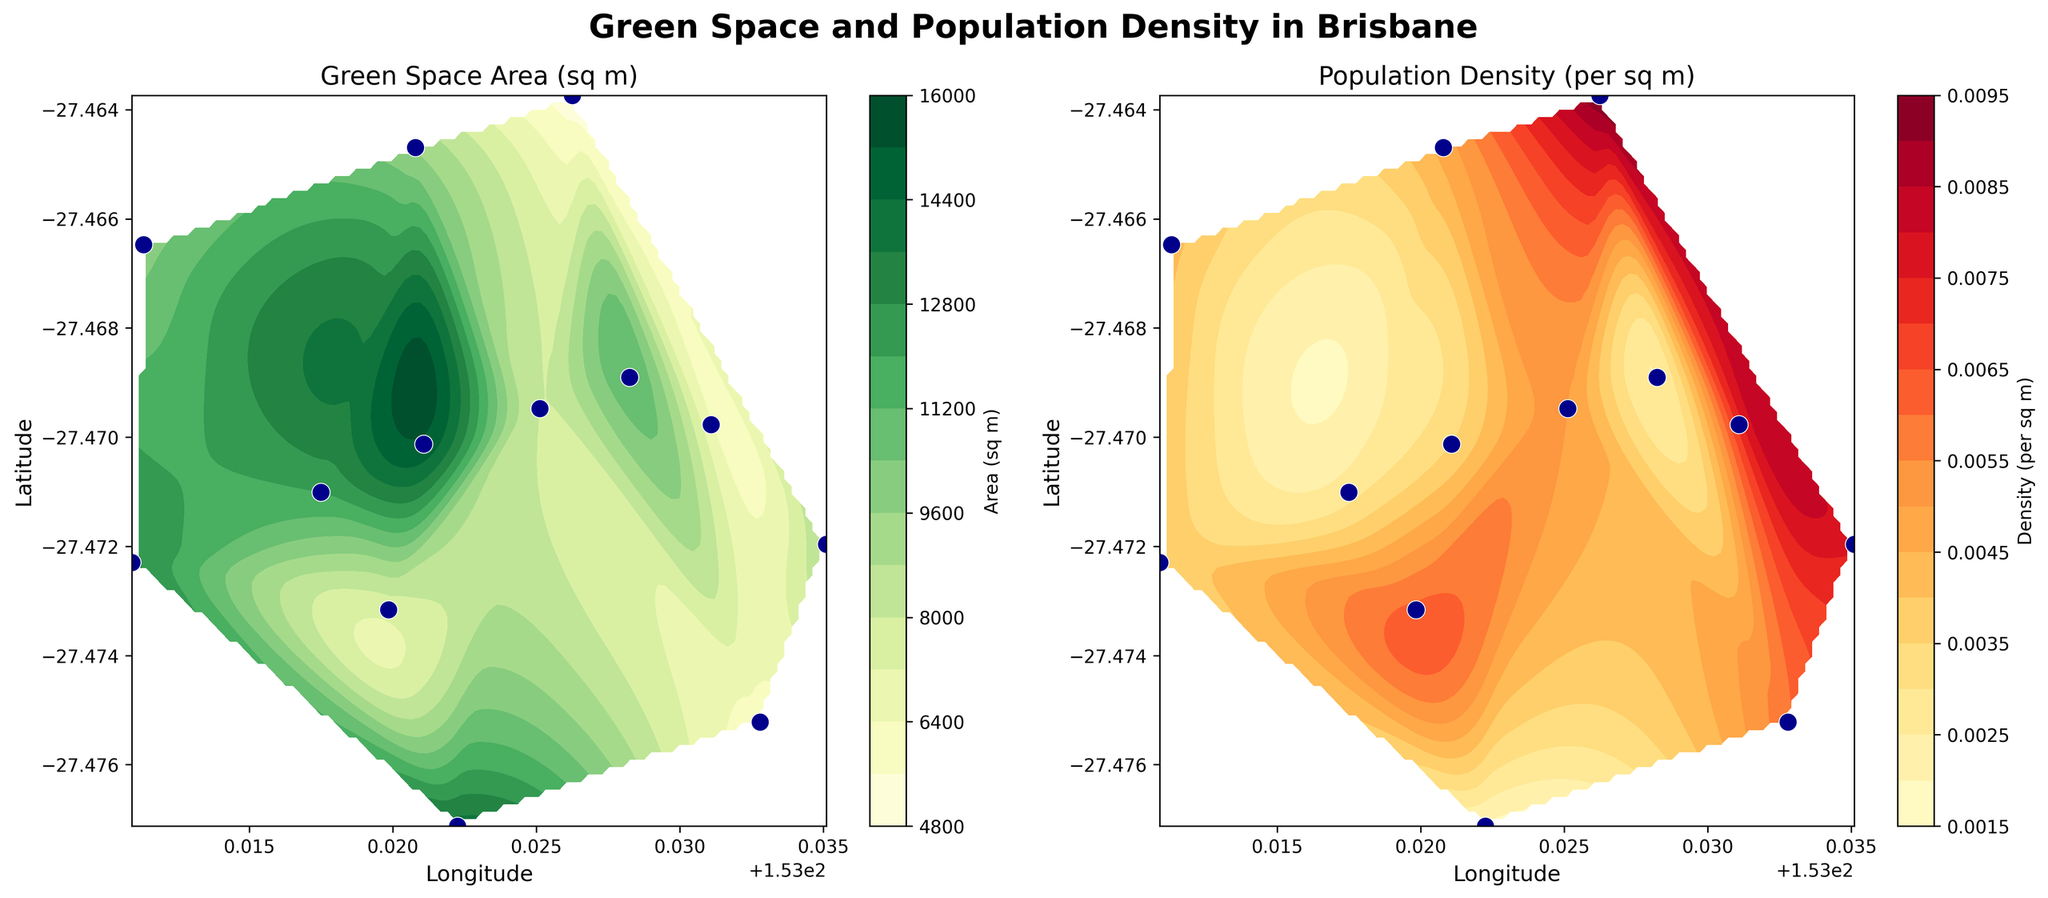What is the title of the figure? The title is placed at the top of the figure, typically in a larger and bold font for emphasis. It provides a summary of what the figure represents.
Answer: Green Space and Population Density in Brisbane What color represents areas with higher green space in the first subplot? The first subplot (on the left) uses a color gradient in the 'YlGn' colormap where lighter yellow indicates lower green space and darker green indicates higher green space.
Answer: Dark green How many subplots are there in the figure? The figure uses a layout with multiple subplots. By counting the separate plots within the figure, we see there are two subplots.
Answer: 2 Which subplot indicates population density? The subplot titles provide context for what each part of the figure represents. The second subplot (on the right) indicates population density based on its title.
Answer: The right subplot What is the green space area near the point with latitude -27.471010 and longitude 153.017492? Locate the point with the specified latitude and longitude on the first subplot and examine the contour lines and color gradient at that point. It is marked with scatter points.
Answer: Around 12000 sq m Which area has a higher population density: near longitude 153.032793 or longitude 153.010913? Compare the color gradients at the two specified longitudes in the second subplot. Darker reds represent higher population density.
Answer: Longitude 153.032793 Is there a correlation between green space and population density in the same region? To determine correlation visually, observe if regions with high green space (darker green) correspond with high population density (darker red) or vice versa. Spatial correlation means we look for overlapping areas with distinct coloration patterns.
Answer: Generally, less green space corresponds to higher population density Which region appears to have the least green space but high population density, based on the contour maps? Identify the area in the first subplot (left) with the lightest yellow shade (least green space) and cross-reference it with the darkest red shade (highest population density) in the second subplot (right).
Answer: Latitude -27.463734, Longitude 153.026246 What is the general trend observed between green space and population density in the center of Brisbane? In the center of the contour plots, observe and compare color gradients for green space in the first subplot and population density in the second subplot. Both subplots should be analyzed together for spatial patterns.
Answer: Areas with lower green space tend to have higher population density What does the color bar represent on each subplot? The color bar on the left side of each subplot clarifies what the colors in the contour represent; the left subplot's color bar indicates green space area (sq m), and the right subplot's color bar indicates population density (per sq m).
Answer: Green space area for the left, population density for the right 